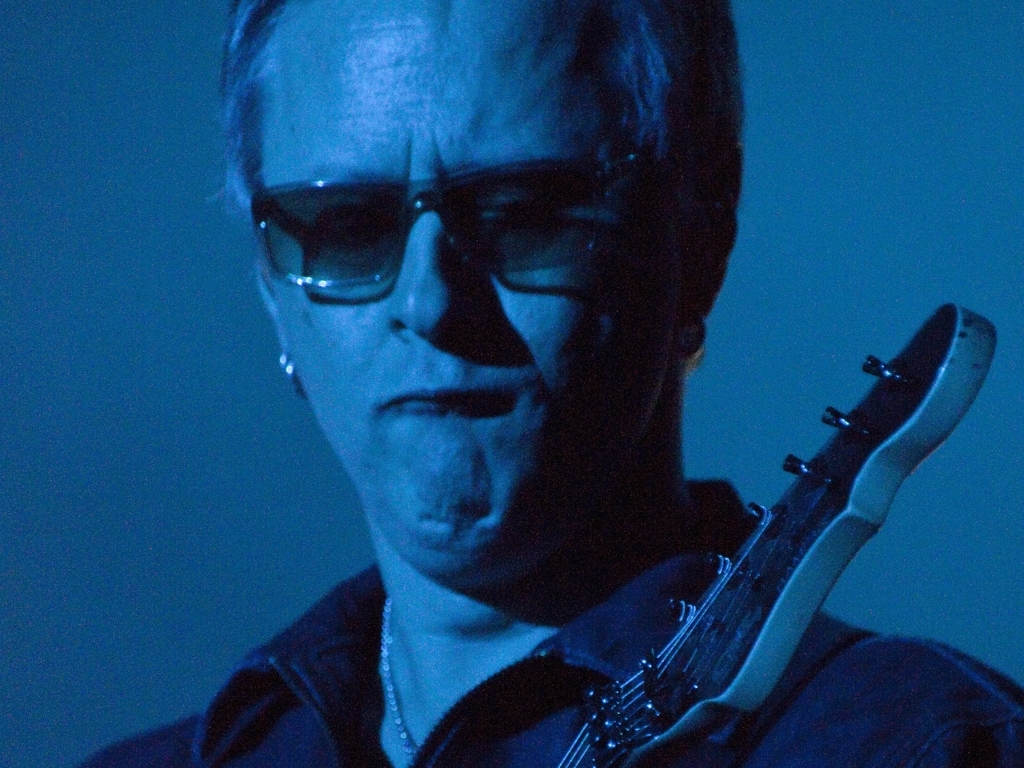What emotional response might the viewer have to the combination of the subject's expression and the image's color palette? The viewer might experience a mix of emotions, such as nostalgia or introspection, triggered by the subject's concentrated expression and the cool, monochromatic blue of the image. This combination can evoke a sense of seriousness and depth, suggesting that the subject is profoundly connected to the music they're playing, which might, in turn, stir a deep emotional response in the audience. 